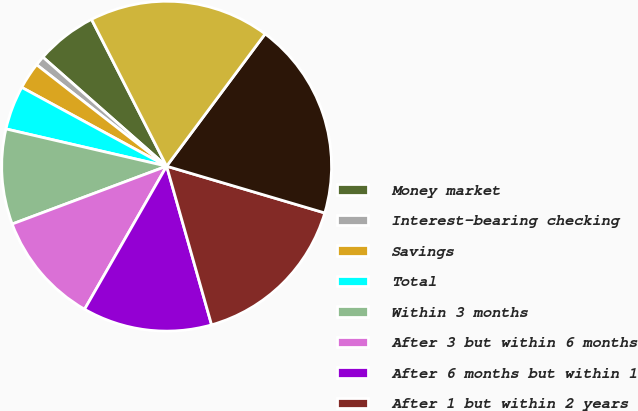<chart> <loc_0><loc_0><loc_500><loc_500><pie_chart><fcel>Money market<fcel>Interest-bearing checking<fcel>Savings<fcel>Total<fcel>Within 3 months<fcel>After 3 but within 6 months<fcel>After 6 months but within 1<fcel>After 1 but within 2 years<fcel>After 2 but within 3 years<fcel>After 3 but within 4 years<nl><fcel>5.98%<fcel>0.95%<fcel>2.62%<fcel>4.3%<fcel>9.33%<fcel>11.01%<fcel>12.68%<fcel>16.03%<fcel>19.39%<fcel>17.71%<nl></chart> 